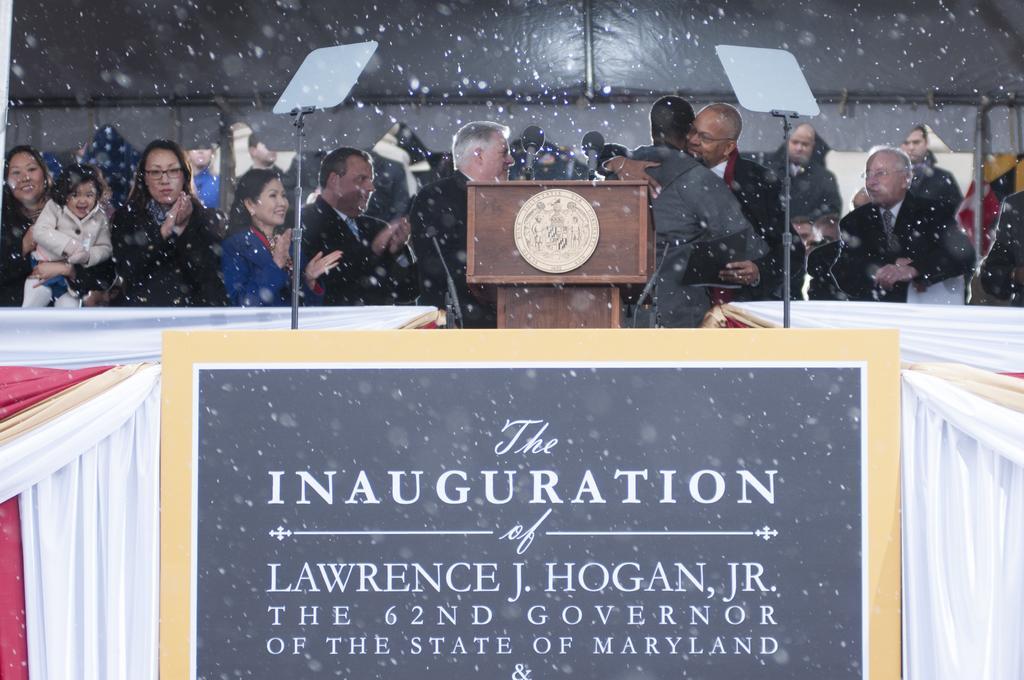Can you describe this image briefly? In the picture I can see group of people are standing. Here I can see a black color board which has something written on it. I can also see white color curtains, podium and some other objects. 